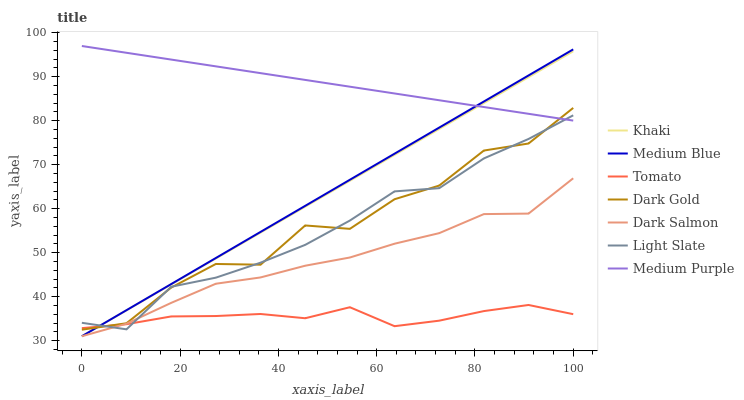Does Tomato have the minimum area under the curve?
Answer yes or no. Yes. Does Medium Purple have the maximum area under the curve?
Answer yes or no. Yes. Does Khaki have the minimum area under the curve?
Answer yes or no. No. Does Khaki have the maximum area under the curve?
Answer yes or no. No. Is Medium Purple the smoothest?
Answer yes or no. Yes. Is Dark Gold the roughest?
Answer yes or no. Yes. Is Khaki the smoothest?
Answer yes or no. No. Is Khaki the roughest?
Answer yes or no. No. Does Khaki have the lowest value?
Answer yes or no. Yes. Does Dark Gold have the lowest value?
Answer yes or no. No. Does Medium Purple have the highest value?
Answer yes or no. Yes. Does Khaki have the highest value?
Answer yes or no. No. Is Dark Salmon less than Dark Gold?
Answer yes or no. Yes. Is Dark Gold greater than Dark Salmon?
Answer yes or no. Yes. Does Khaki intersect Medium Blue?
Answer yes or no. Yes. Is Khaki less than Medium Blue?
Answer yes or no. No. Is Khaki greater than Medium Blue?
Answer yes or no. No. Does Dark Salmon intersect Dark Gold?
Answer yes or no. No. 